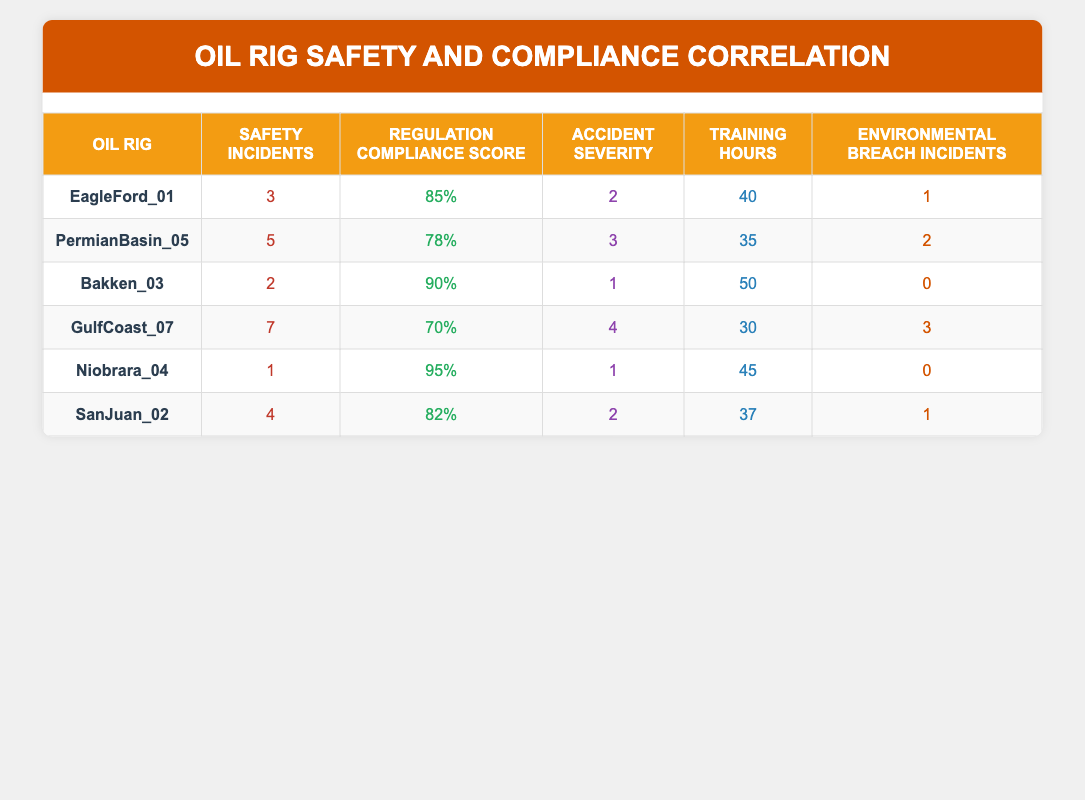What is the highest Regulation Compliance Score among the oil rigs? Looking at the Regulation Compliance Score column, Bakken_03 has the highest score of 90%.
Answer: 90% How many Safety Incidents are recorded for GulfCoast_07? The table shows that GulfCoast_07 has recorded 7 Safety Incidents.
Answer: 7 What is the average number of Training Hours across all oil rigs? To find the average, we add the Training Hours for all rigs (40 + 35 + 50 + 30 + 45 + 37 = 237) and divide by the number of rigs (6). The average is 237 / 6 = 39.5.
Answer: 39.5 Is there any oil rig with zero Environmental Breach Incidents? Yes, Bakken_03 and Niobrara_04 both have zero Environmental Breach Incidents recorded.
Answer: Yes Which oil rig has the lowest Safety Incidents and how many are there? The lowest number of Safety Incidents is found in Niobrara_04 with only 1 incident.
Answer: 1 Calculate the total number of Environmental Breach Incidents across all oil rigs. The total is the sum of Environmental Breach Incidents: 1 + 2 + 0 + 3 + 0 + 1 = 7 incidents in total.
Answer: 7 Does a higher Regulation Compliance Score correlate with fewer Safety Incidents based on the data? Looking at the data, Bakken_03 has the highest compliance score (90%) and only 2 incidents, while GulfCoast_07 has the lowest score (70%) and the highest incidents (7). This suggests a negative correlation.
Answer: Yes How many oil rigs have more than 4 Safety Incidents? There are 2 oil rigs with more than 4 Safety Incidents: GulfCoast_07 (7 incidents) and PermianBasin_05 (5 incidents).
Answer: 2 What is the relationship between Training Hours and Safety Incidents in these rigs? By comparing the Training Hours with Safety Incidents, GulfCoast_07 with the lowest Training Hours (30) has the highest Safety Incidents (7), while Bakken_03 with 50 hours has only 2 incidents. This suggests that more training hours might correlate with fewer incidents, indicating a possible positive relationship.
Answer: Positive relationship 